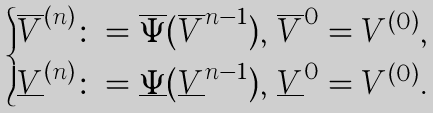<formula> <loc_0><loc_0><loc_500><loc_500>\begin{cases} \overline { V } ^ { ( n ) } \colon = \overline { \Psi } ( \overline { V } ^ { n - 1 } ) , \, \overline { V } ^ { 0 } = V ^ { ( 0 ) } , \\ \underline { V } ^ { ( n ) } \colon = \underline { \Psi } ( \underline { V } ^ { n - 1 } ) , \, \underline { V } ^ { 0 } = V ^ { ( 0 ) } . \end{cases}</formula> 